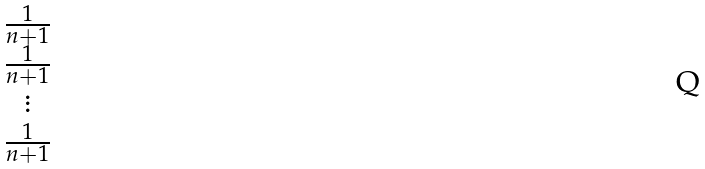<formula> <loc_0><loc_0><loc_500><loc_500>\begin{matrix} \frac { 1 } { n + 1 } \\ \frac { 1 } { n + 1 } \\ \vdots \\ \frac { 1 } { n + 1 } \end{matrix}</formula> 